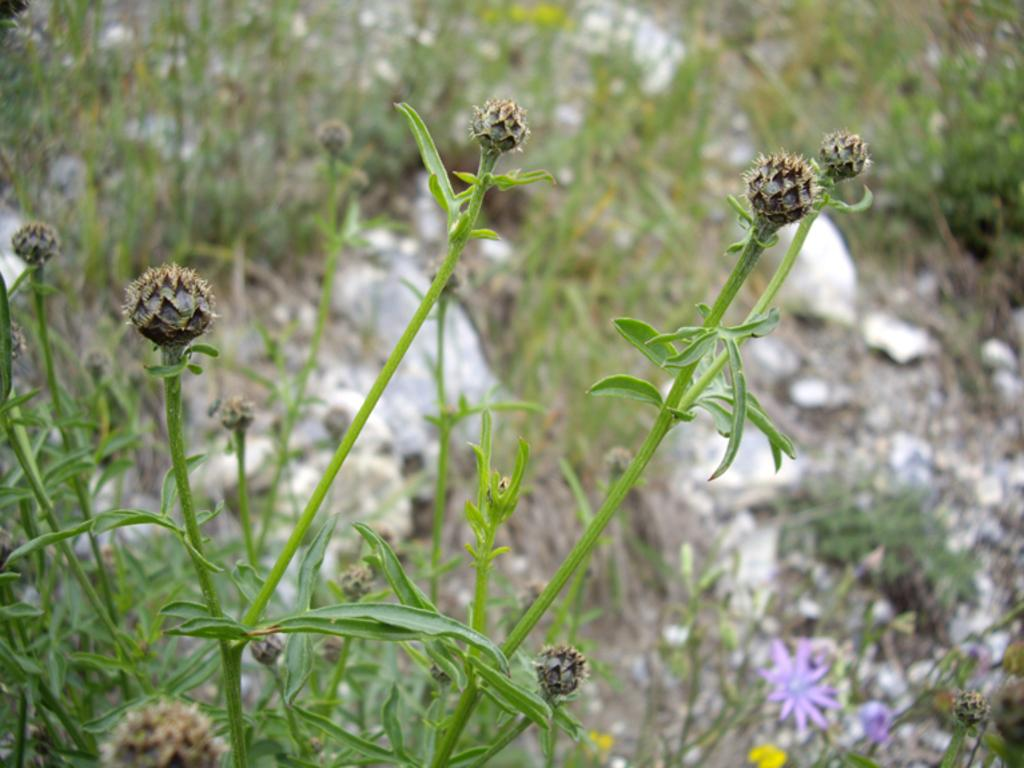What type of living organisms can be seen in the image? Plants can be seen in the image. Can you describe the background of the image? The background of the image is blurred. What type of whistle can be heard in the image? There is no whistle present in the image, as it is a still image and does not contain any sounds. 